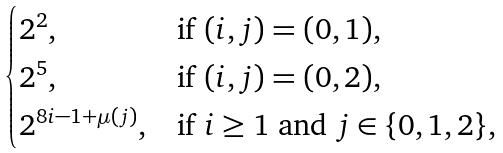<formula> <loc_0><loc_0><loc_500><loc_500>\begin{cases} 2 ^ { 2 } , & \text {if $(i,j)    = (0,1)$,} \\ 2 ^ { 5 } , & \text {if $(i,j)=(0,2)$,} \\ 2 ^ { 8 i - 1 + \mu ( j ) } , & \text {if $i \geq 1$ and $j \in \{0,1,2\}$,} \end{cases}</formula> 